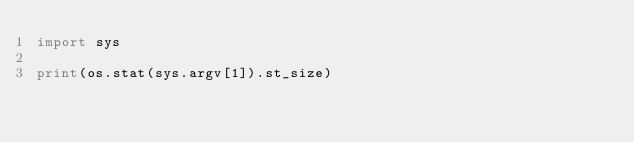<code> <loc_0><loc_0><loc_500><loc_500><_Python_>import sys

print(os.stat(sys.argv[1]).st_size)
</code> 